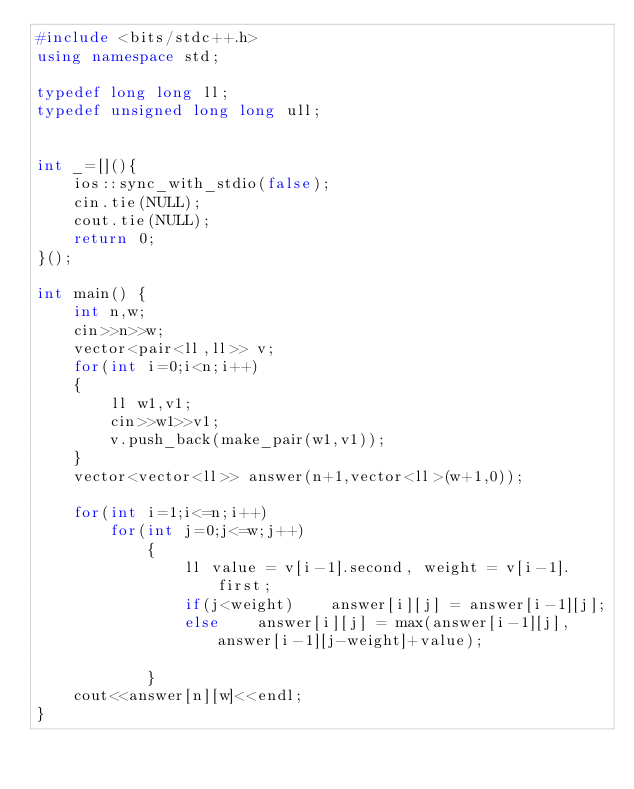<code> <loc_0><loc_0><loc_500><loc_500><_C++_>#include <bits/stdc++.h>
using namespace std;

typedef long long ll;
typedef unsigned long long ull;


int _=[](){
    ios::sync_with_stdio(false);
    cin.tie(NULL);
    cout.tie(NULL);
    return 0;
}();

int main() {
    int n,w;
    cin>>n>>w;
    vector<pair<ll,ll>> v;
    for(int i=0;i<n;i++)
    {
        ll w1,v1;
        cin>>w1>>v1;
        v.push_back(make_pair(w1,v1));
    }
    vector<vector<ll>> answer(n+1,vector<ll>(w+1,0));
    
    for(int i=1;i<=n;i++)
        for(int j=0;j<=w;j++)
            {
                ll value = v[i-1].second, weight = v[i-1].first;
                if(j<weight)    answer[i][j] = answer[i-1][j];
                else    answer[i][j] = max(answer[i-1][j], answer[i-1][j-weight]+value);
                
            }
    cout<<answer[n][w]<<endl;
}</code> 